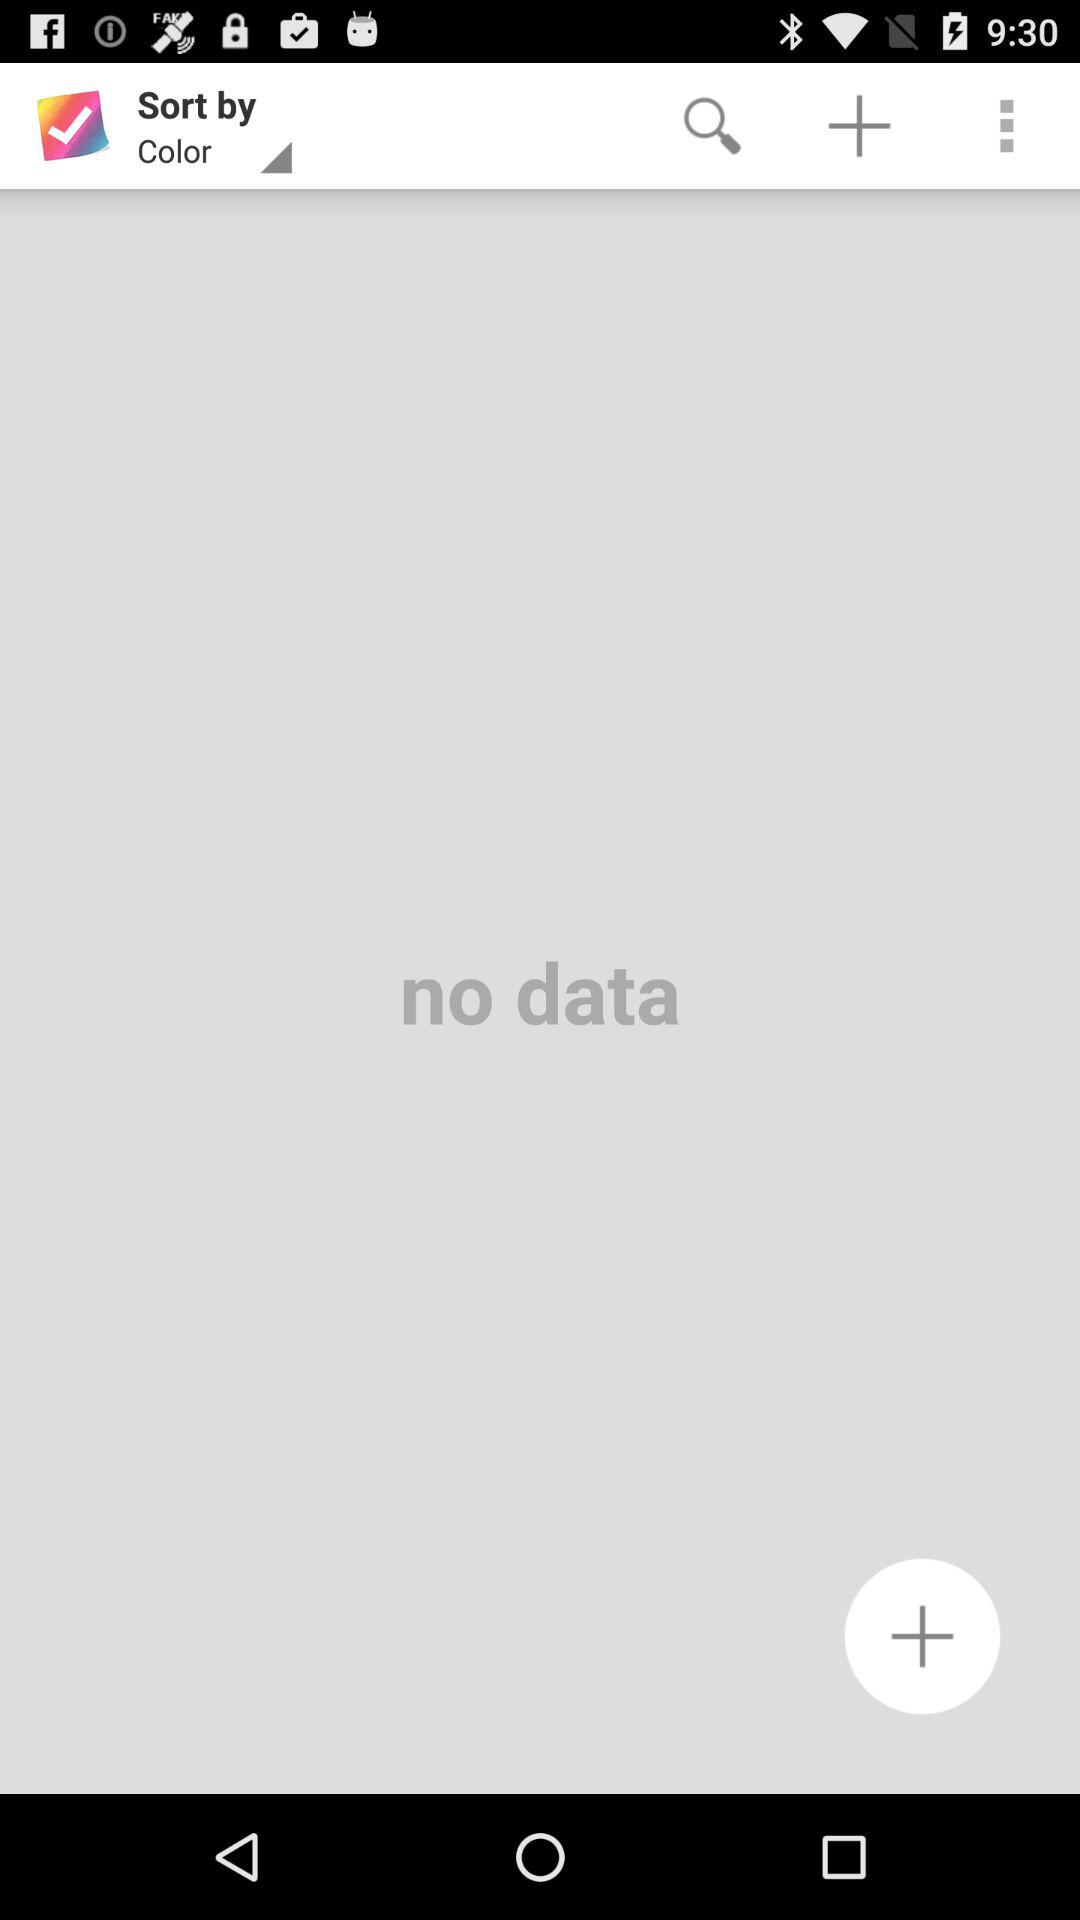What is the selected option in "Sort by"? The selected option in "Sort by" is "Color". 